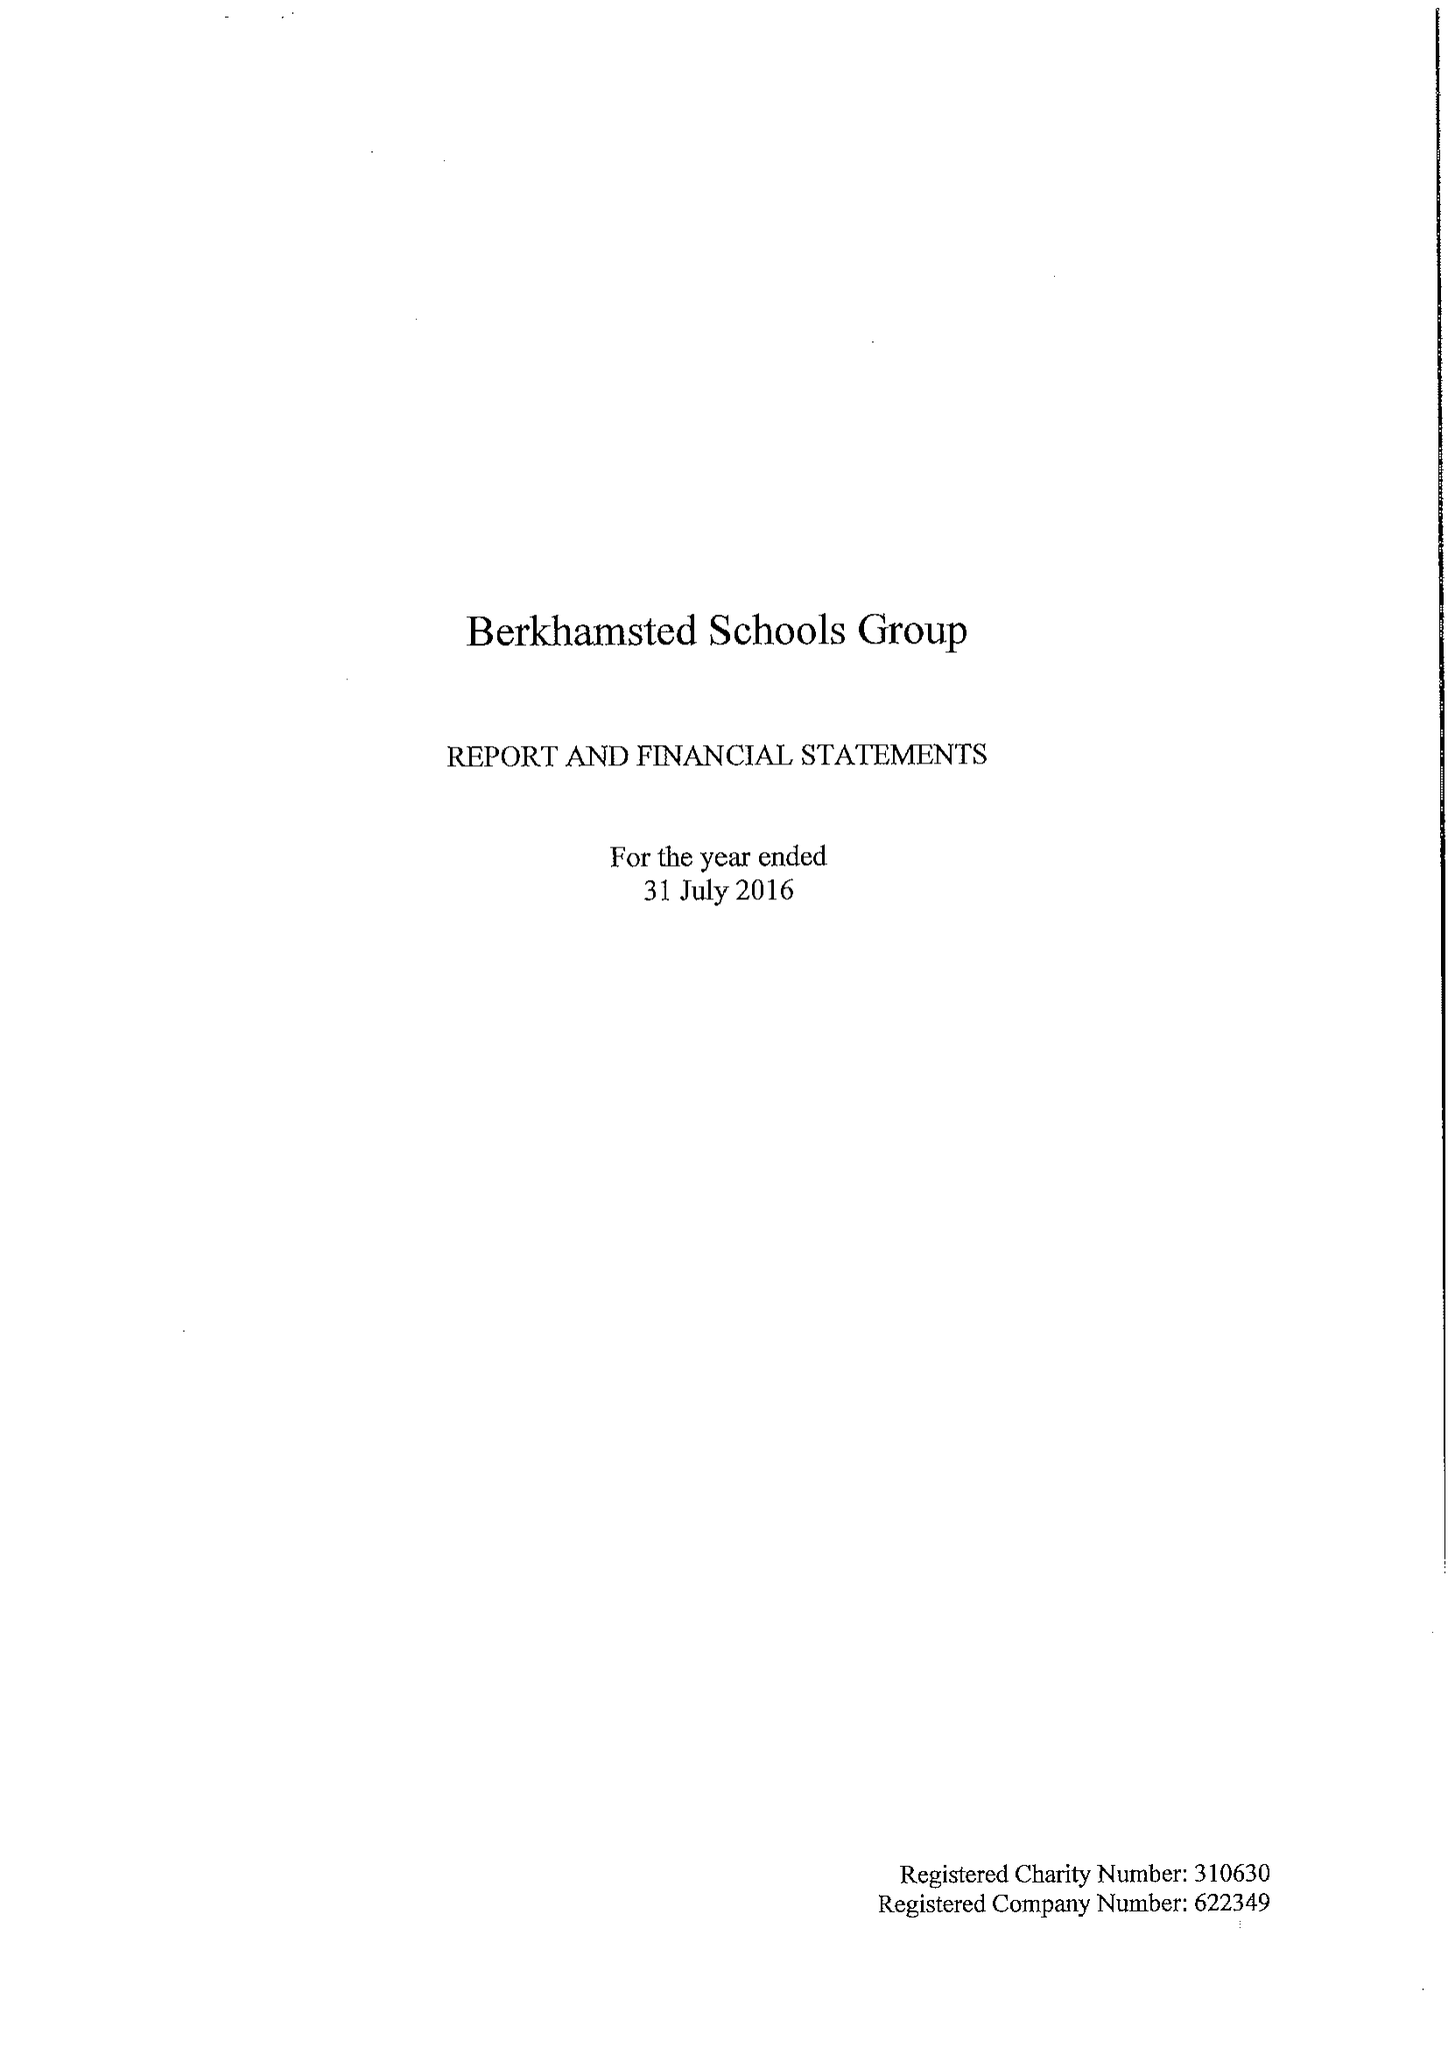What is the value for the address__post_town?
Answer the question using a single word or phrase. BERKHAMSTED 